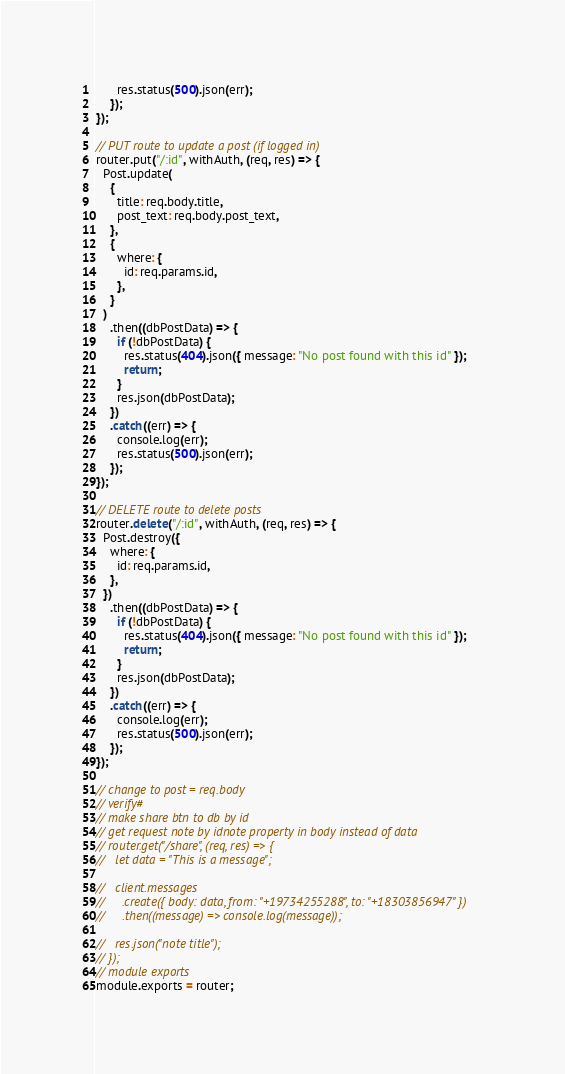<code> <loc_0><loc_0><loc_500><loc_500><_JavaScript_>      res.status(500).json(err);
    });
});

// PUT route to update a post (if logged in)
router.put("/:id", withAuth, (req, res) => {
  Post.update(
    {
      title: req.body.title,
      post_text: req.body.post_text,
    },
    {
      where: {
        id: req.params.id,
      },
    }
  )
    .then((dbPostData) => {
      if (!dbPostData) {
        res.status(404).json({ message: "No post found with this id" });
        return;
      }
      res.json(dbPostData);
    })
    .catch((err) => {
      console.log(err);
      res.status(500).json(err);
    });
});

// DELETE route to delete posts
router.delete("/:id", withAuth, (req, res) => {
  Post.destroy({
    where: {
      id: req.params.id,
    },
  })
    .then((dbPostData) => {
      if (!dbPostData) {
        res.status(404).json({ message: "No post found with this id" });
        return;
      }
      res.json(dbPostData);
    })
    .catch((err) => {
      console.log(err);
      res.status(500).json(err);
    });
});

// change to post = req.body
// verify#
// make share btn to db by id
// get request note by idnote property in body instead of data
// router.get("/share", (req, res) => {
//   let data = "This is a message";

//   client.messages
//     .create({ body: data, from: "+19734255288", to: "+18303856947" })
//     .then((message) => console.log(message));

//   res.json("note title");
// });
// module exports
module.exports = router;
</code> 